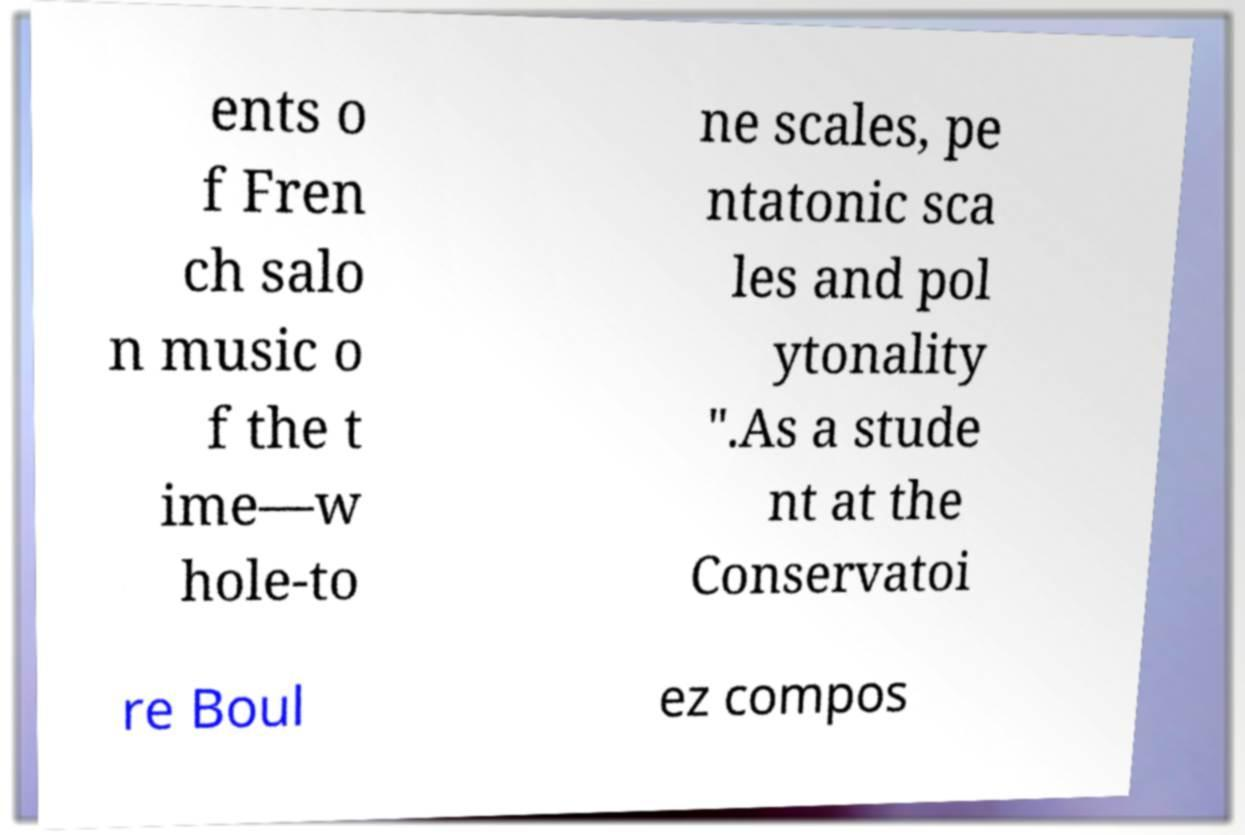There's text embedded in this image that I need extracted. Can you transcribe it verbatim? ents o f Fren ch salo n music o f the t ime—w hole-to ne scales, pe ntatonic sca les and pol ytonality ".As a stude nt at the Conservatoi re Boul ez compos 